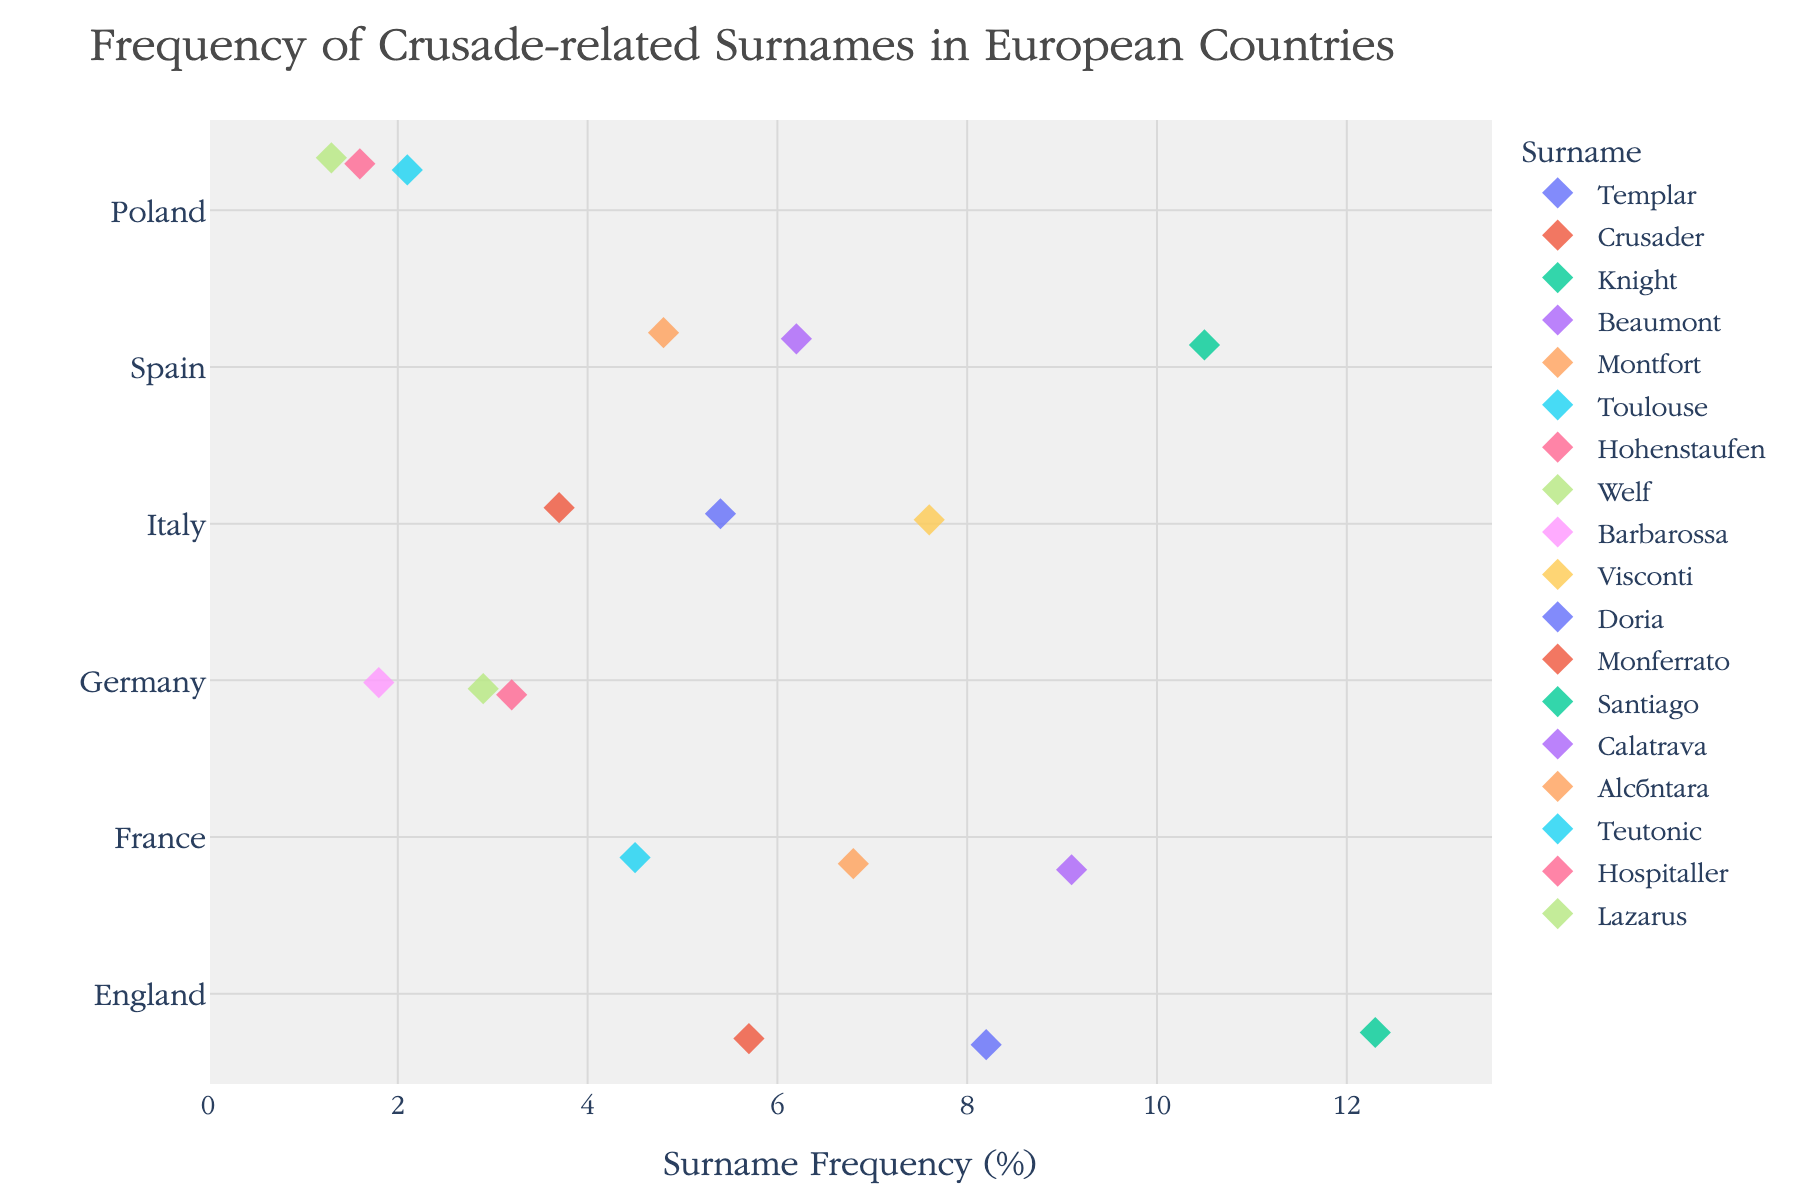What's the title of the plot? The title of the plot is located at the top, written in a larger font size than the rest of the text. It reads, "Frequency of Crusade-related Surnames in European Countries".
Answer: Frequency of Crusade-related Surnames in European Countries Which surname has the highest frequency in England? To find this, look at the 'England' group on the y-axis and identify the surname with the highest point on the x-axis. The 'Knight' surname has the highest frequency at 12.3%.
Answer: Knight How many surnames are plotted for France? Count the number of points associated with 'France' on the plot. There are points for 'Beaumont', 'Montfort', and 'Toulouse', totaling three.
Answer: 3 What is the range of surname frequencies in Spain? Find the lowest and highest points for surnames in Spain. The lowest frequency is 4.8% (Alcántara) and the highest is 10.5% (Santiago). The range is 10.5 - 4.8 = 5.7%.
Answer: 5.7% Which country has the lowest frequency surname, and what is it? Scan the plot for the lowest point on the x-axis. The lowest frequency is 1.3%, which belongs to 'Lazarus' in Poland.
Answer: Poland, Lazarus What is the median frequency of surnames in Italy? First, list the frequencies for Italy: 7.6 (Visconti), 5.4 (Doria), 3.7 (Monferrato). Arrange them in order: 3.7, 5.4, 7.6. Since there are three values, the median is the middle one, which is 5.4.
Answer: 5.4% Compare the highest frequency surname in Germany to the lowest frequency surname in France. Which one is higher and by how much? The highest frequency surname in Germany is 'Hohenstaufen' at 3.2%. The lowest frequency surname in France is 'Toulouse' at 4.5%. 'Toulouse' is higher by 4.5 - 3.2 = 1.3%.
Answer: Toulouse by 1.3% Which country has the most diverse range of surname frequencies? Calculate the range of frequencies for each country. England: 12.3 - 5.7 = 6.6, France: 9.1 - 4.5 = 4.6, Germany: 3.2 - 1.8 = 1.4, Italy: 7.6 - 3.7 = 3.9, Spain: 10.5 - 4.8 = 5.7, Poland: 2.1 - 1.3 = 0.8. England has the highest range of 6.6%.
Answer: England Is there any country where all surname frequencies are below 5%? Check each country for all frequencies below 5%. Poland has 2.1, 1.6, and 1.3, which are all below 5%.
Answer: Yes, Poland 